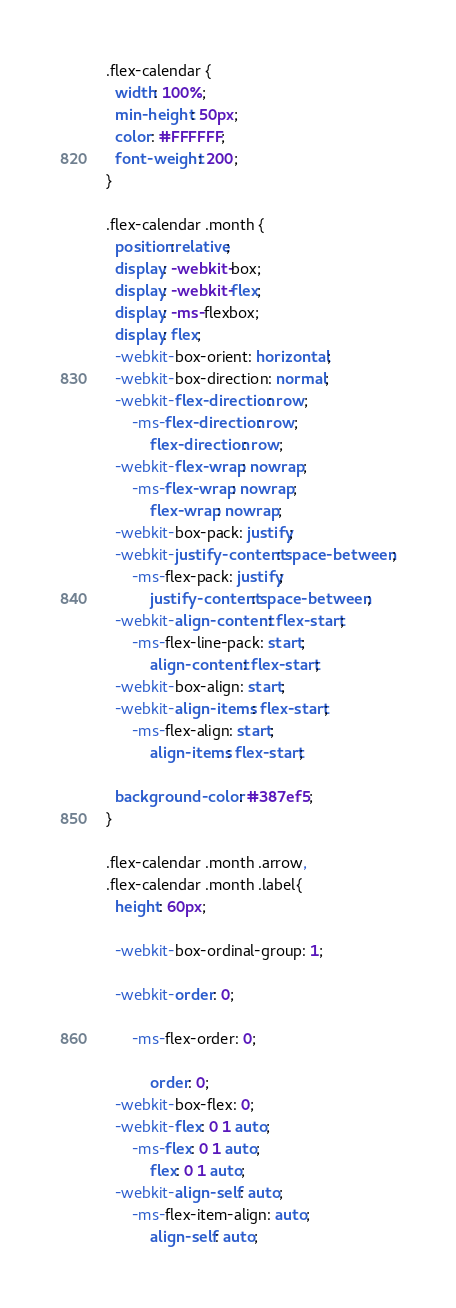Convert code to text. <code><loc_0><loc_0><loc_500><loc_500><_CSS_>.flex-calendar {
  width: 100%;
  min-height: 50px;
  color: #FFFFFF;
  font-weight: 200;
}

.flex-calendar .month {
  position:relative;
  display: -webkit-box;
  display: -webkit-flex;
  display: -ms-flexbox;
  display: flex;
  -webkit-box-orient: horizontal;
  -webkit-box-direction: normal;
  -webkit-flex-direction: row;
      -ms-flex-direction: row;
          flex-direction: row;
  -webkit-flex-wrap: nowrap;
      -ms-flex-wrap: nowrap;
          flex-wrap: nowrap;
  -webkit-box-pack: justify;
  -webkit-justify-content: space-between;
      -ms-flex-pack: justify;
          justify-content: space-between;
  -webkit-align-content: flex-start;
      -ms-flex-line-pack: start;
          align-content: flex-start;
  -webkit-box-align: start;
  -webkit-align-items: flex-start;
      -ms-flex-align: start;
          align-items: flex-start;

  background-color: #387ef5;
}

.flex-calendar .month .arrow,
.flex-calendar .month .label{
  height: 60px;

  -webkit-box-ordinal-group: 1;

  -webkit-order: 0;

      -ms-flex-order: 0;

          order: 0;
  -webkit-box-flex: 0;
  -webkit-flex: 0 1 auto;
      -ms-flex: 0 1 auto;
          flex: 0 1 auto;
  -webkit-align-self: auto;
      -ms-flex-item-align: auto;
          align-self: auto;</code> 